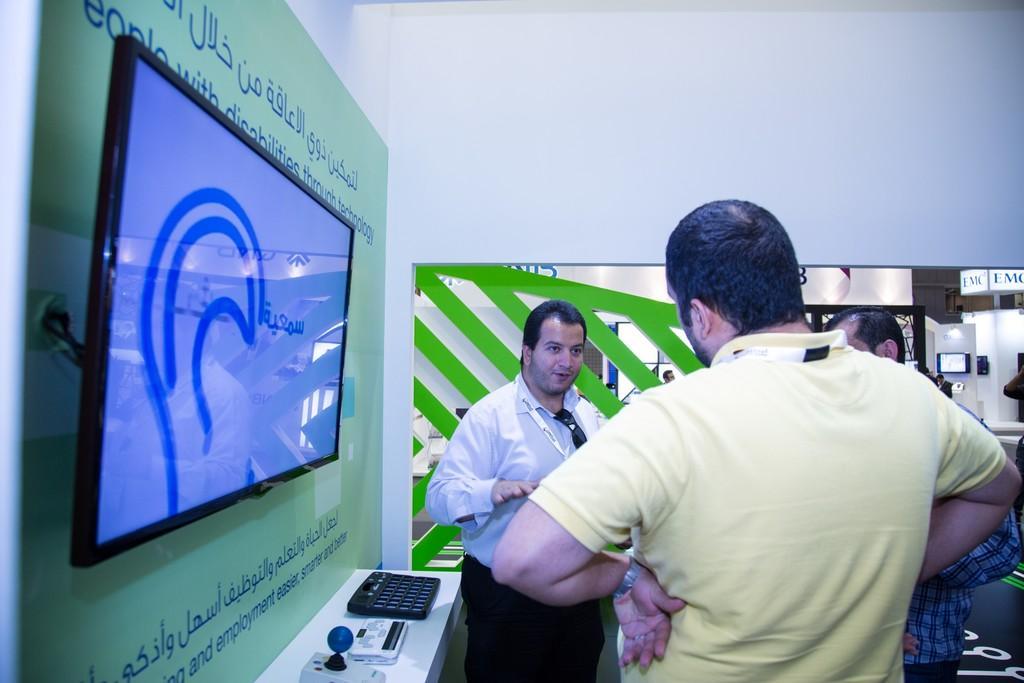Could you give a brief overview of what you see in this image? In this image there are three persons in the middle who are talking with each other. On the left side there is a wall to which there is a television. Below the television there is a wall on which there is a joystick. In the background there are few other televisions. It seems like a store. On the wall there is some text. 